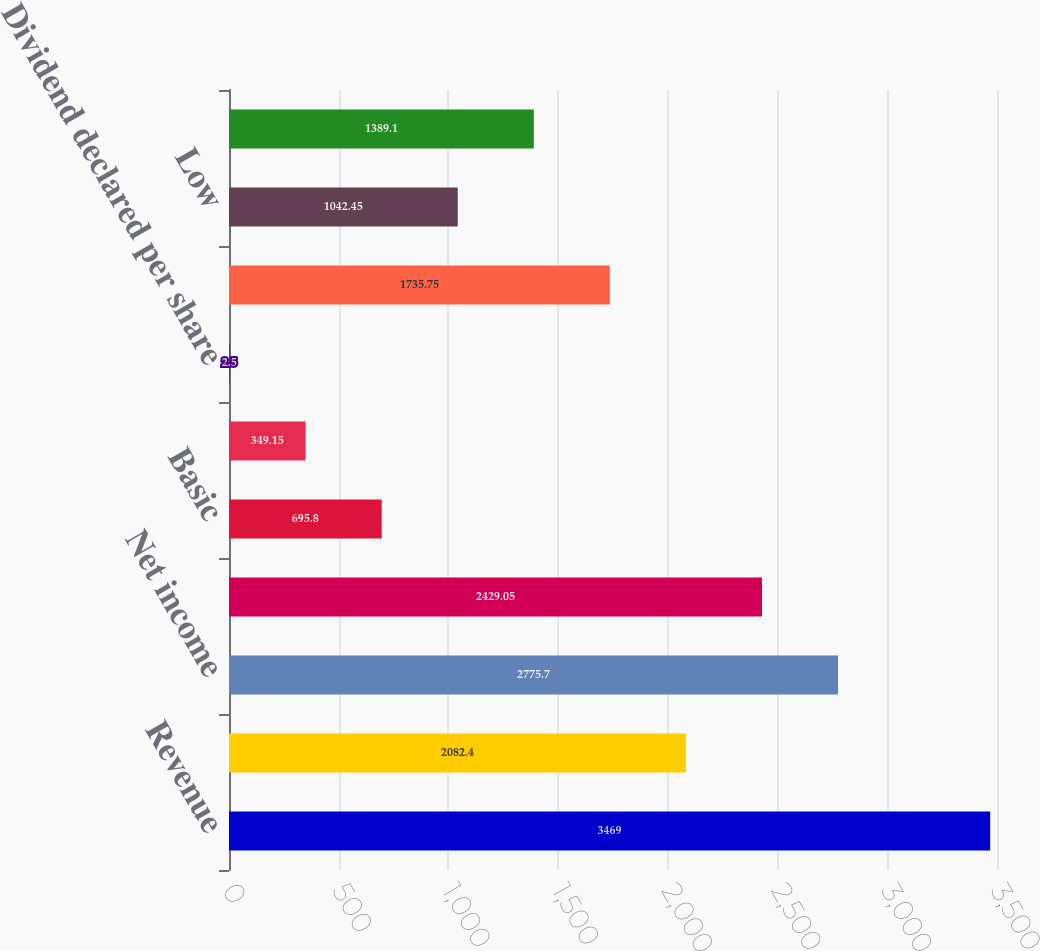Convert chart to OTSL. <chart><loc_0><loc_0><loc_500><loc_500><bar_chart><fcel>Revenue<fcel>Operating income<fcel>Net income<fcel>Net income attributable to<fcel>Basic<fcel>Diluted<fcel>Dividend declared per share<fcel>High<fcel>Low<fcel>Close<nl><fcel>3469<fcel>2082.4<fcel>2775.7<fcel>2429.05<fcel>695.8<fcel>349.15<fcel>2.5<fcel>1735.75<fcel>1042.45<fcel>1389.1<nl></chart> 